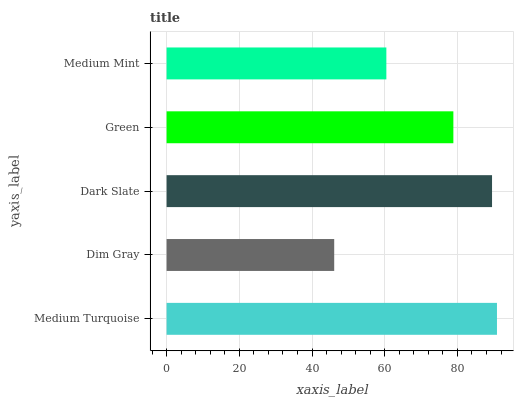Is Dim Gray the minimum?
Answer yes or no. Yes. Is Medium Turquoise the maximum?
Answer yes or no. Yes. Is Dark Slate the minimum?
Answer yes or no. No. Is Dark Slate the maximum?
Answer yes or no. No. Is Dark Slate greater than Dim Gray?
Answer yes or no. Yes. Is Dim Gray less than Dark Slate?
Answer yes or no. Yes. Is Dim Gray greater than Dark Slate?
Answer yes or no. No. Is Dark Slate less than Dim Gray?
Answer yes or no. No. Is Green the high median?
Answer yes or no. Yes. Is Green the low median?
Answer yes or no. Yes. Is Medium Turquoise the high median?
Answer yes or no. No. Is Dim Gray the low median?
Answer yes or no. No. 